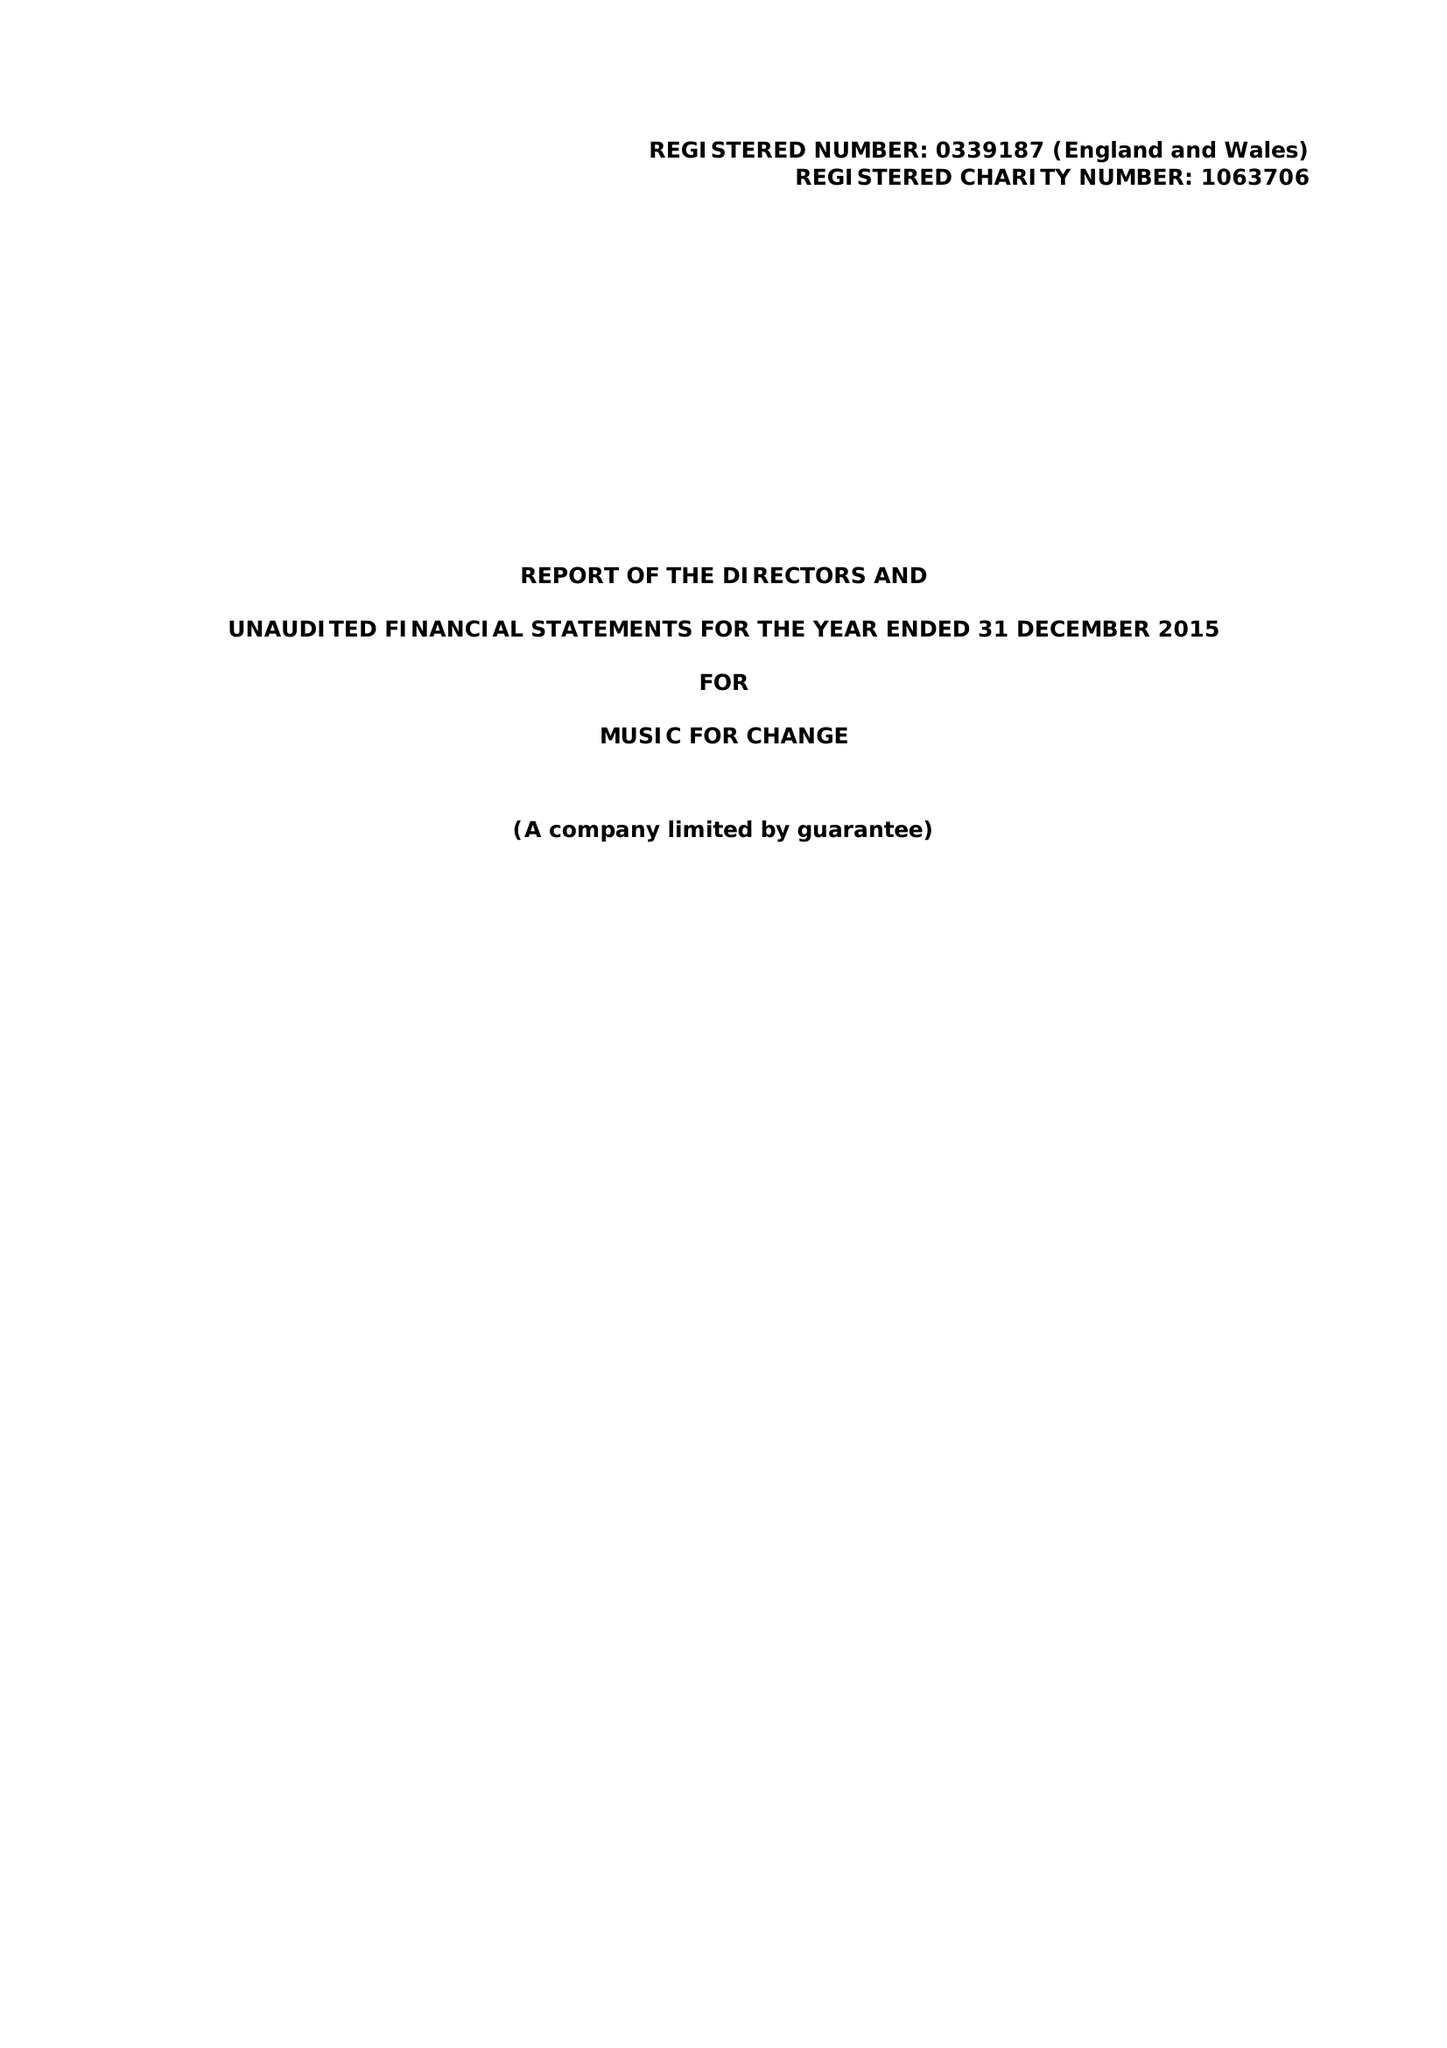What is the value for the report_date?
Answer the question using a single word or phrase. 2015-12-31 